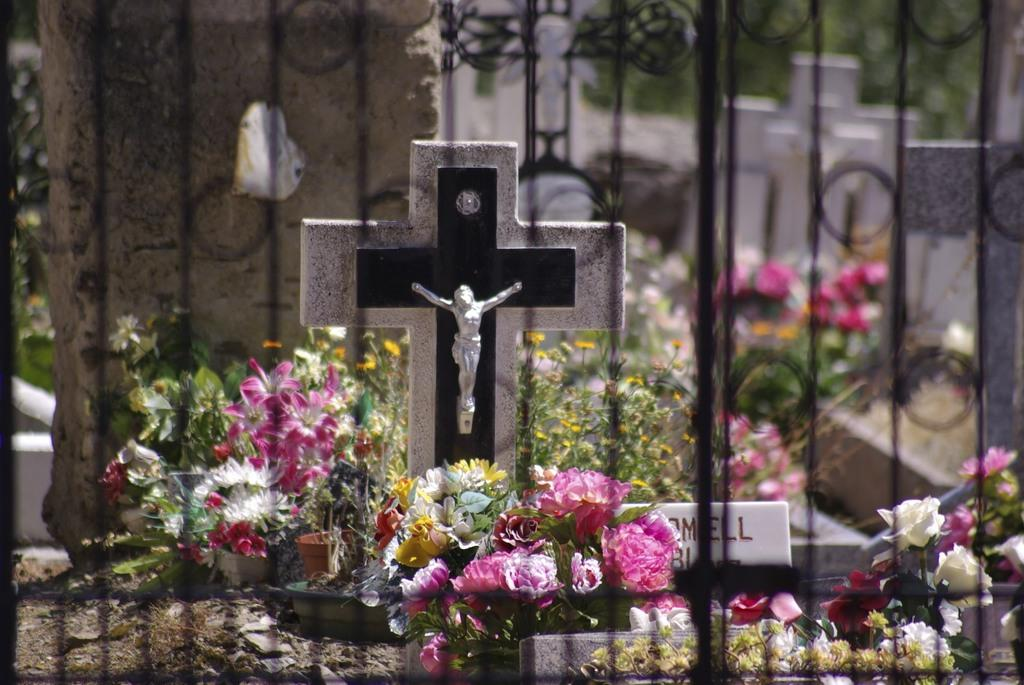What type of location is depicted in the image? There is a cemetery in the picture. Are there any additional elements present in the image? Yes, there are flowers around the cemetery. What type of beef can be seen hanging from the trees in the image? There is no beef present in the image; it features a cemetery with flowers around it. What type of wrench is being used to maintain the trains in the image? There are no trains or wrenches present in the image. 